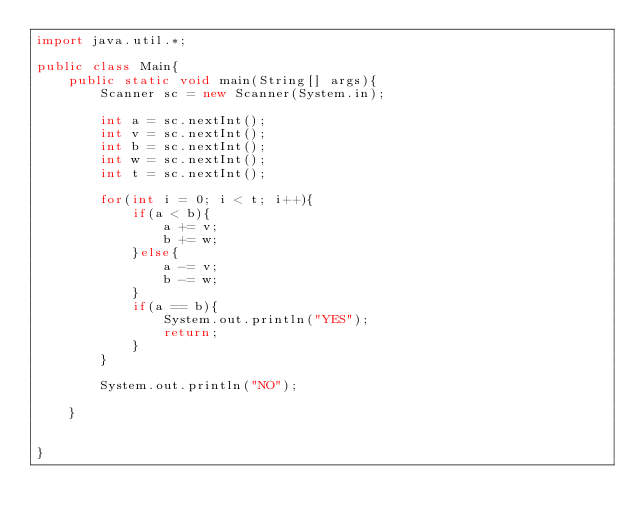<code> <loc_0><loc_0><loc_500><loc_500><_Java_>import java.util.*;

public class Main{
    public static void main(String[] args){
        Scanner sc = new Scanner(System.in);

        int a = sc.nextInt();
        int v = sc.nextInt();
        int b = sc.nextInt();
        int w = sc.nextInt();
        int t = sc.nextInt();

        for(int i = 0; i < t; i++){
            if(a < b){
                a += v;
                b += w;
            }else{
                a -= v;
                b -= w;
            }
            if(a == b){
                System.out.println("YES");
                return;
            }
        }

        System.out.println("NO");

    }


}
</code> 